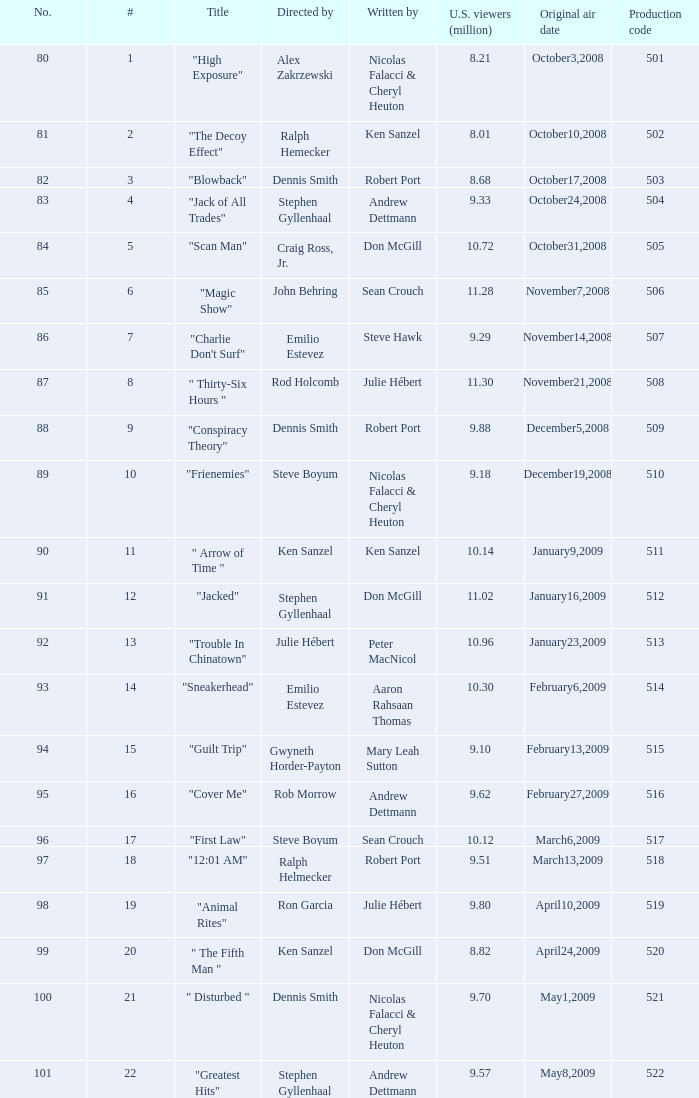What is the production code for the episode that had 9.18 million viewers (U.S.)? 510.0. 